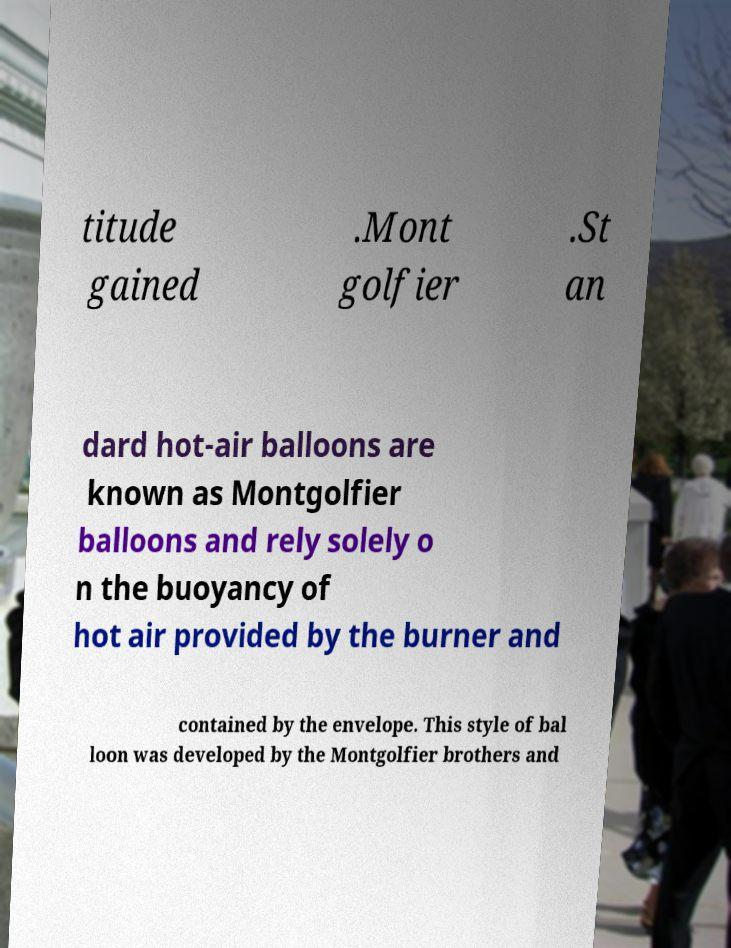Could you assist in decoding the text presented in this image and type it out clearly? titude gained .Mont golfier .St an dard hot-air balloons are known as Montgolfier balloons and rely solely o n the buoyancy of hot air provided by the burner and contained by the envelope. This style of bal loon was developed by the Montgolfier brothers and 